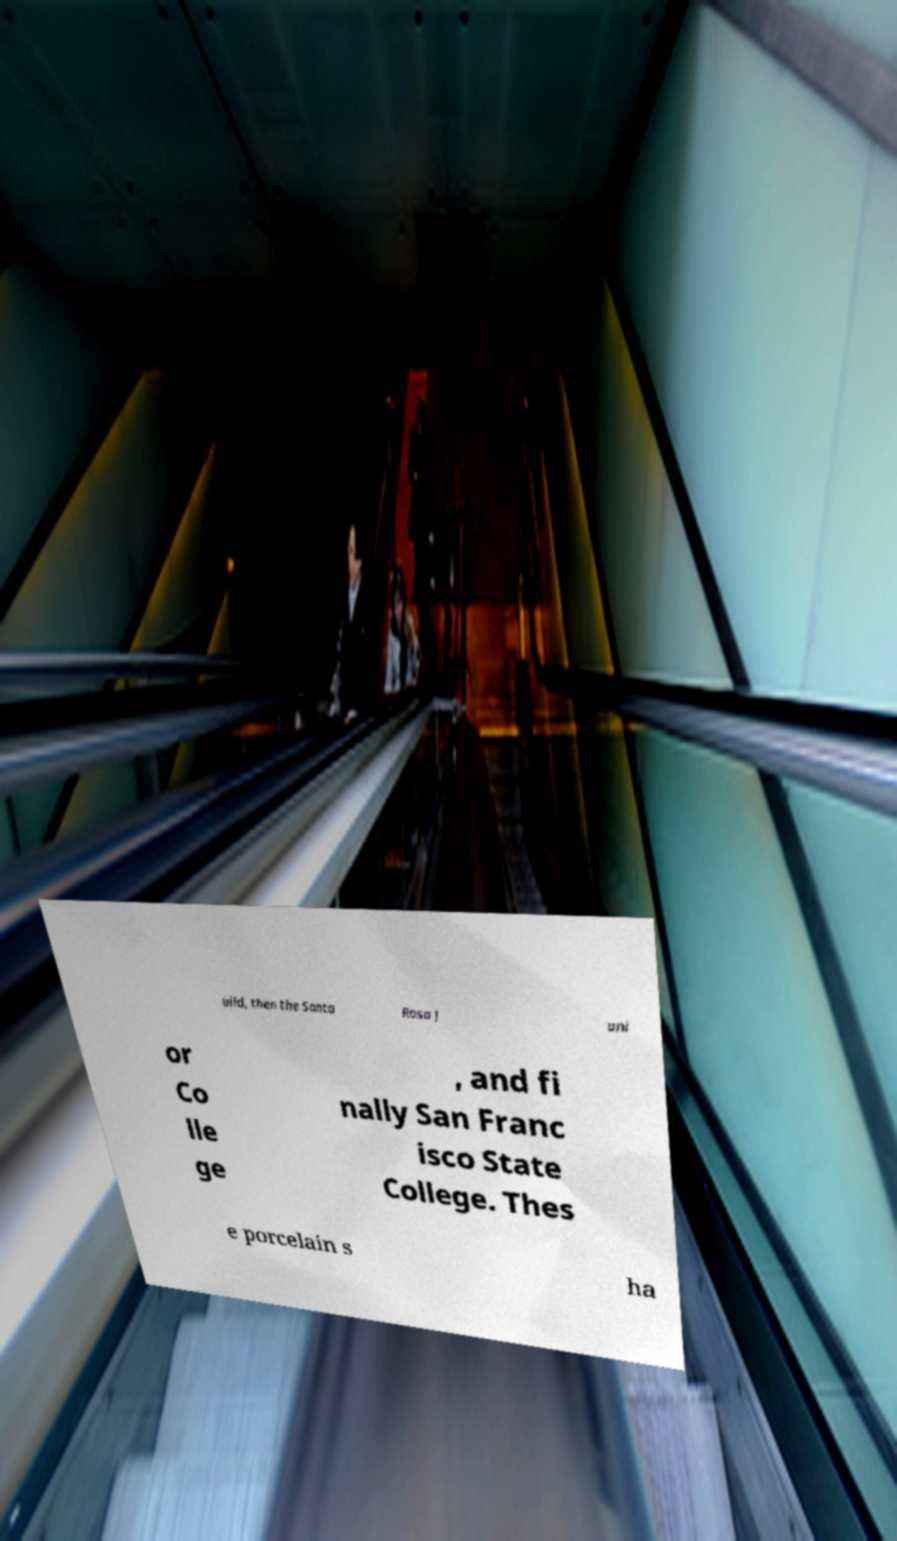Please identify and transcribe the text found in this image. uild, then the Santa Rosa J uni or Co lle ge , and fi nally San Franc isco State College. Thes e porcelain s ha 